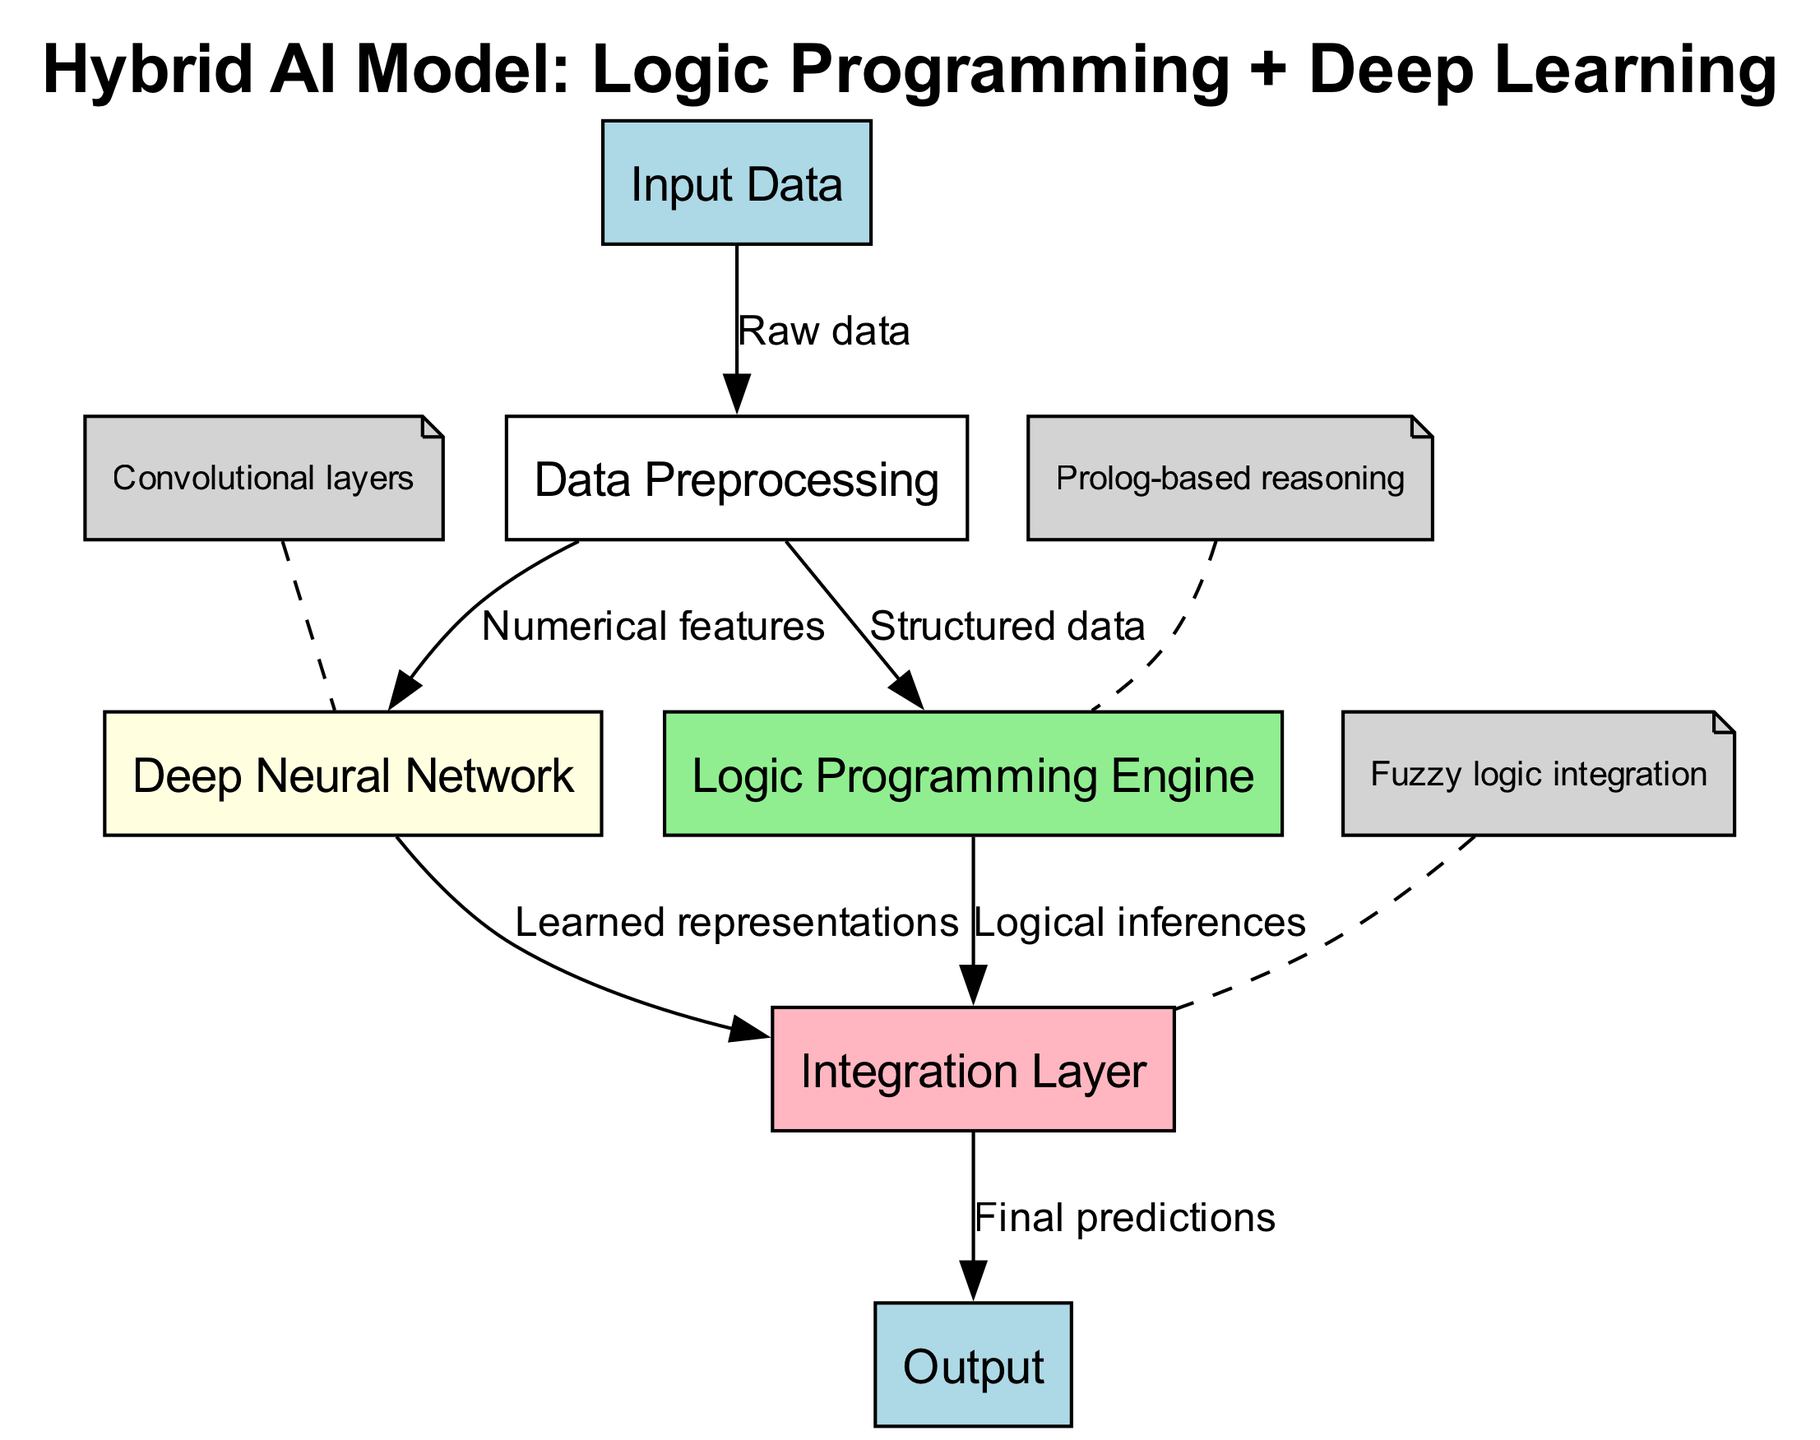What is the first step that occurs after receiving input data? The first step is "Data Preprocessing," where raw data is transformed into a structured format suitable for further processing.
Answer: Data Preprocessing Which node is responsible for generating logical inferences? The "Logic Programming Engine" is responsible for generating logical inferences based on the structured data input it receives after preprocessing.
Answer: Logic Programming Engine How many nodes are present in the diagram? There are six nodes represented in the diagram: Input Data, Data Preprocessing, Logic Programming Engine, Deep Neural Network, Integration Layer, and Output.
Answer: Six What two types of data are sent from the Data Preprocessing node? The Data Preprocessing node sends "Structured data" to the Logic Programming Engine and "Numerical features" to the Deep Neural Network, indicating it handles different types of data for different processing engines.
Answer: Structured data and Numerical features What kind of logic integration is employed in the Integration Layer? The Integration Layer employs "Fuzzy logic integration," which combines the outputs from the Logic Programming Engine and the Deep Neural Network into a single coherent output.
Answer: Fuzzy logic integration Which part of the process outputs the final predictions? The final predictions are outputted from the "Output" node, which receives processed information from the Integration Layer.
Answer: Output What is the main function of the Deep Neural Network node? The Deep Neural Network node functions to produce "Learned representations" through its convolutional layers, effectively learning patterns from the numerical features derived from the preprocessing stage.
Answer: Learned representations What is the relationship between the Logic Programming Engine and the Integration Layer? The Logic Programming Engine sends its results, labeled as "Logical inferences," directly to the Integration Layer, which aggregates these results with those from the Deep Neural Network.
Answer: Logical inferences How is the Logic Programming Engine annotated in the diagram? The Logic Programming Engine is annotated with the text "Prolog-based reasoning," indicating the underlying methodology employed in its logic processing.
Answer: Prolog-based reasoning 